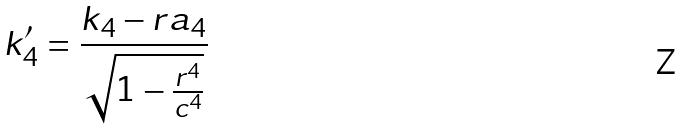Convert formula to latex. <formula><loc_0><loc_0><loc_500><loc_500>k _ { 4 } ^ { \prime } = \frac { k _ { 4 } - r a _ { 4 } } { \sqrt { 1 - \frac { r ^ { 4 } } { c ^ { 4 } } } }</formula> 